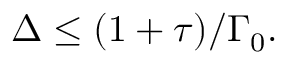<formula> <loc_0><loc_0><loc_500><loc_500>\Delta \leq ( 1 + \tau ) / \Gamma _ { 0 } .</formula> 